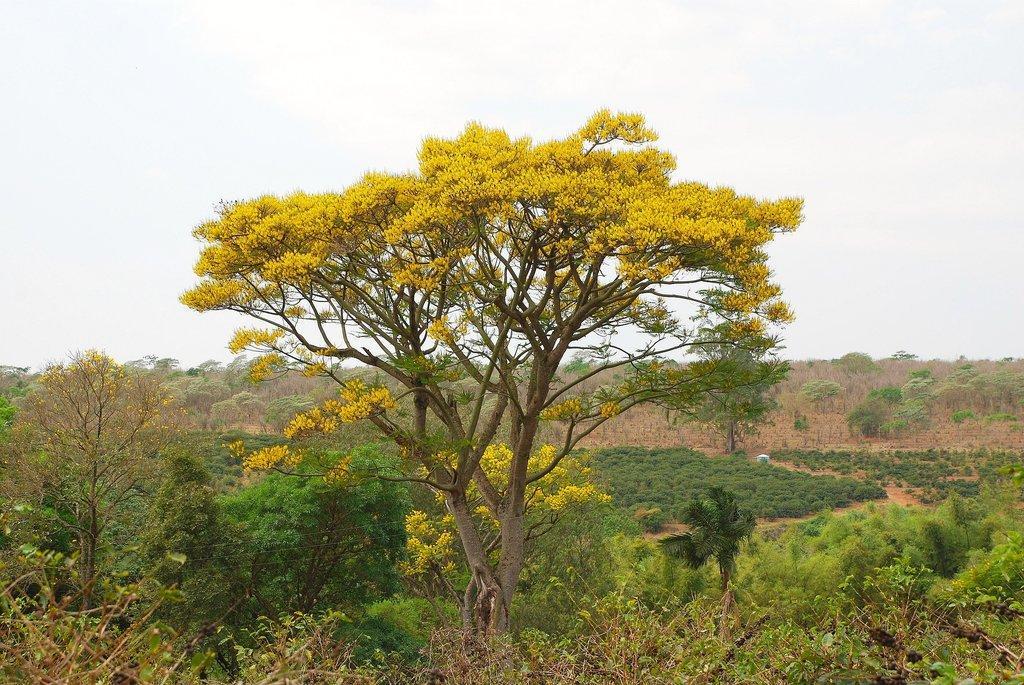Describe this image in one or two sentences. In this image there are few flowers, trees, plants and the sky. 